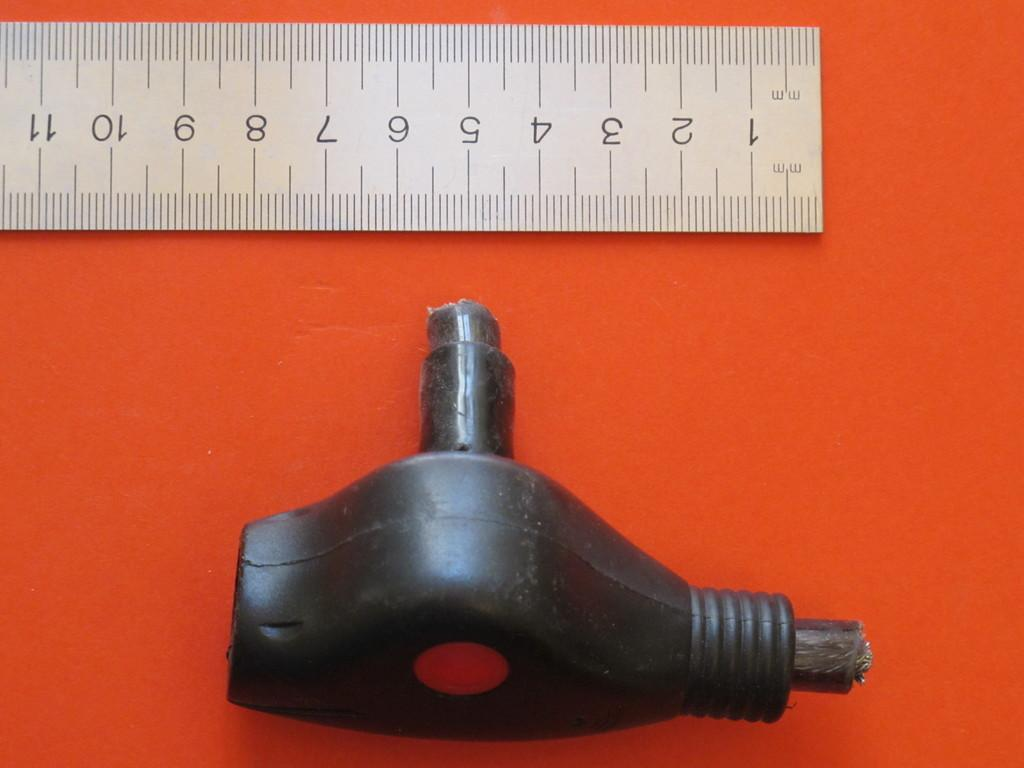<image>
Present a compact description of the photo's key features. A metal ruler shows numbers 1 through 11 mm. 